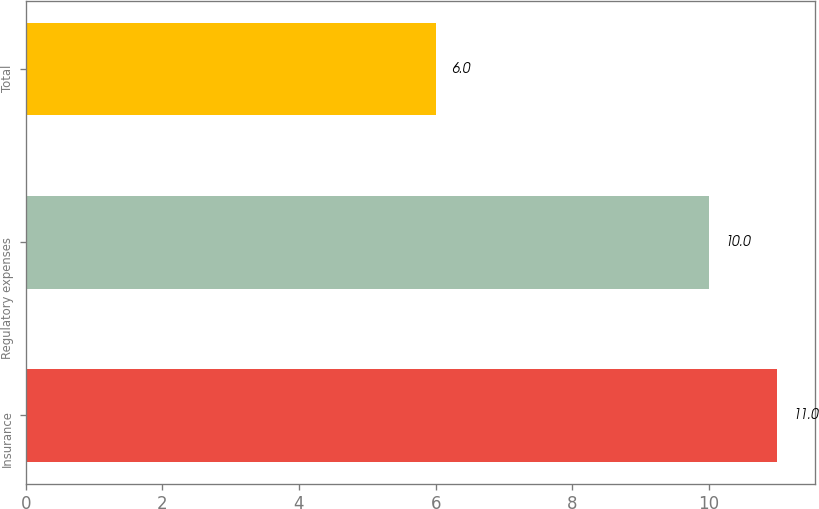Convert chart to OTSL. <chart><loc_0><loc_0><loc_500><loc_500><bar_chart><fcel>Insurance<fcel>Regulatory expenses<fcel>Total<nl><fcel>11<fcel>10<fcel>6<nl></chart> 